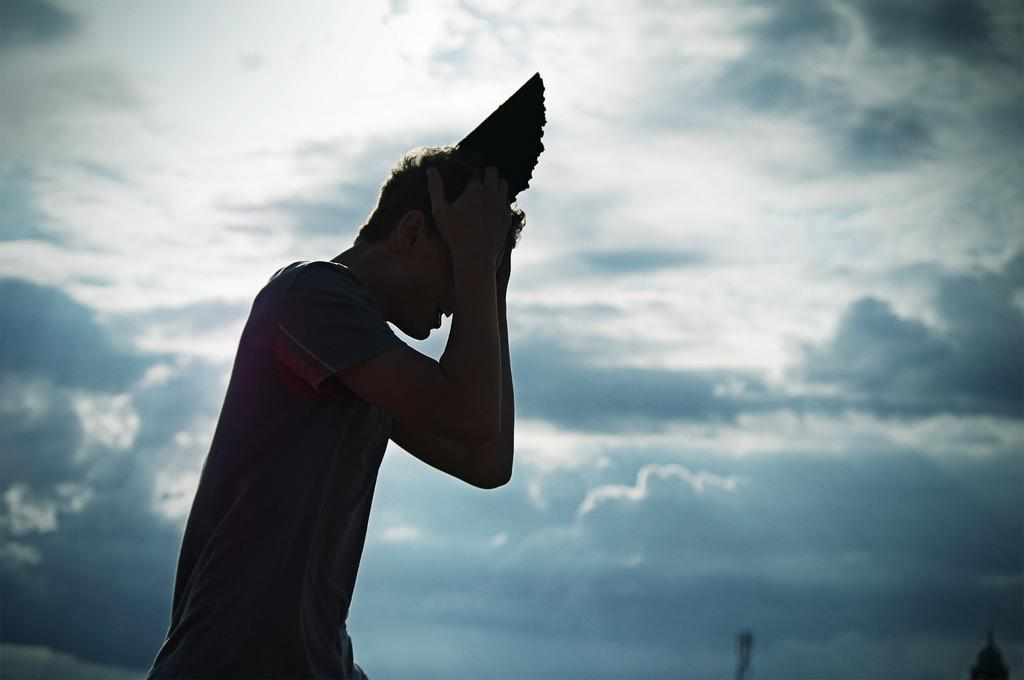What is the main subject in the foreground of the picture? There is a person in the foreground of the picture. What is the person doing with their head? The person is holding their head. Is there anything on the person's head? Yes, there is an object on the person's head. How would you describe the sky in the picture? The sky is cloudy. What is the person pointing at in the picture? There is no indication in the image that the person is pointing at anything. 